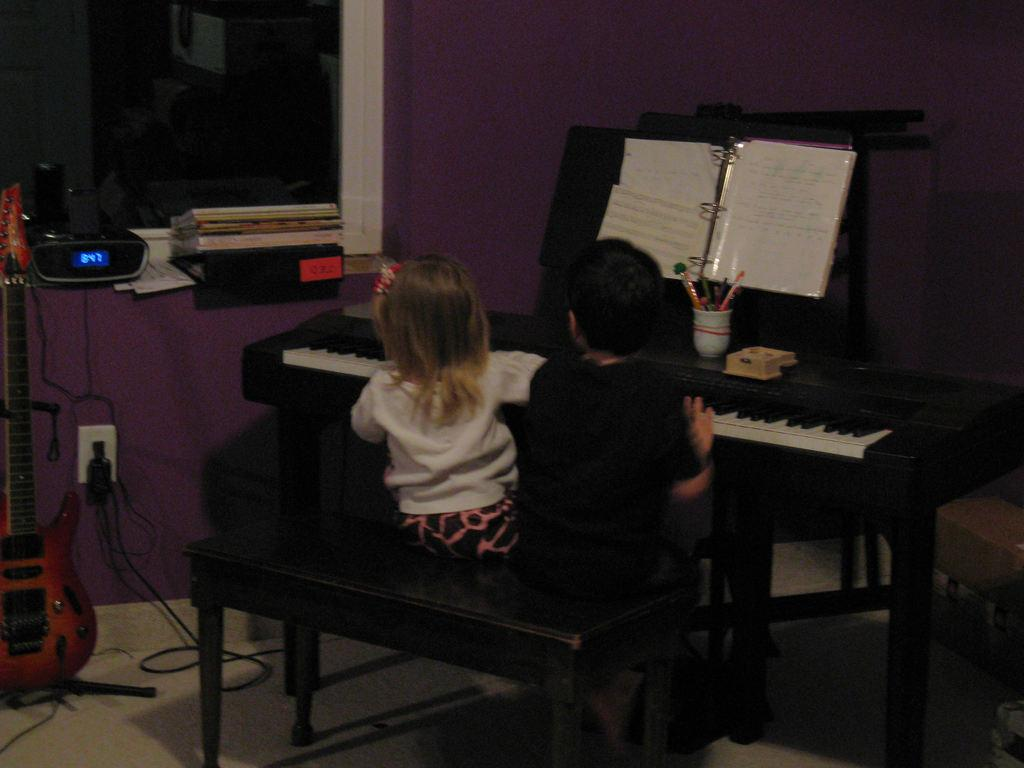What are the kids doing in the image? The kids are playing a piano in the image. What is written on the piano? The piano has a musician script on top of it. What can be seen to the left side of the image? There is a chargeable piano with an electronic gadget to the left side of the image. How much sugar is in the rest of the image? There is no sugar present in the image, and the concept of "rest" does not apply to the image itself. 